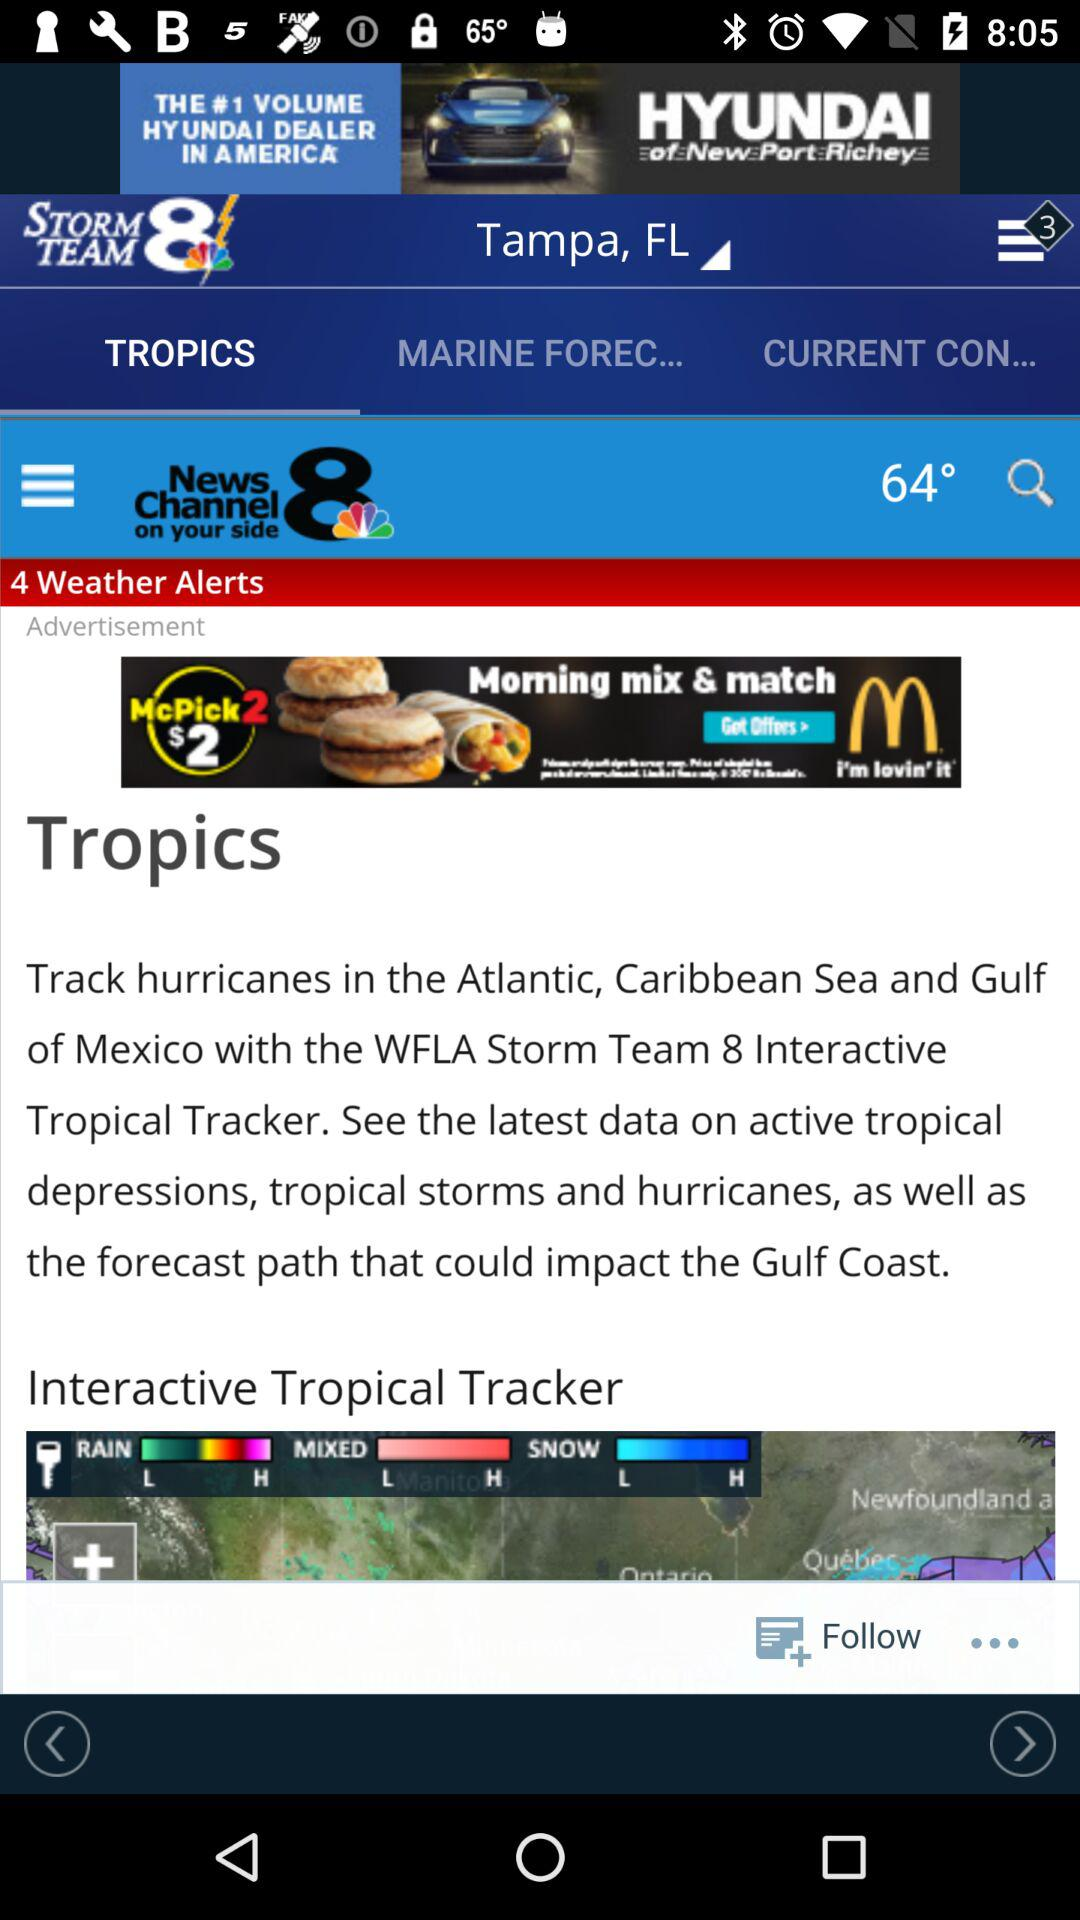Which location is selected? The selected location is Tampa, FL. 